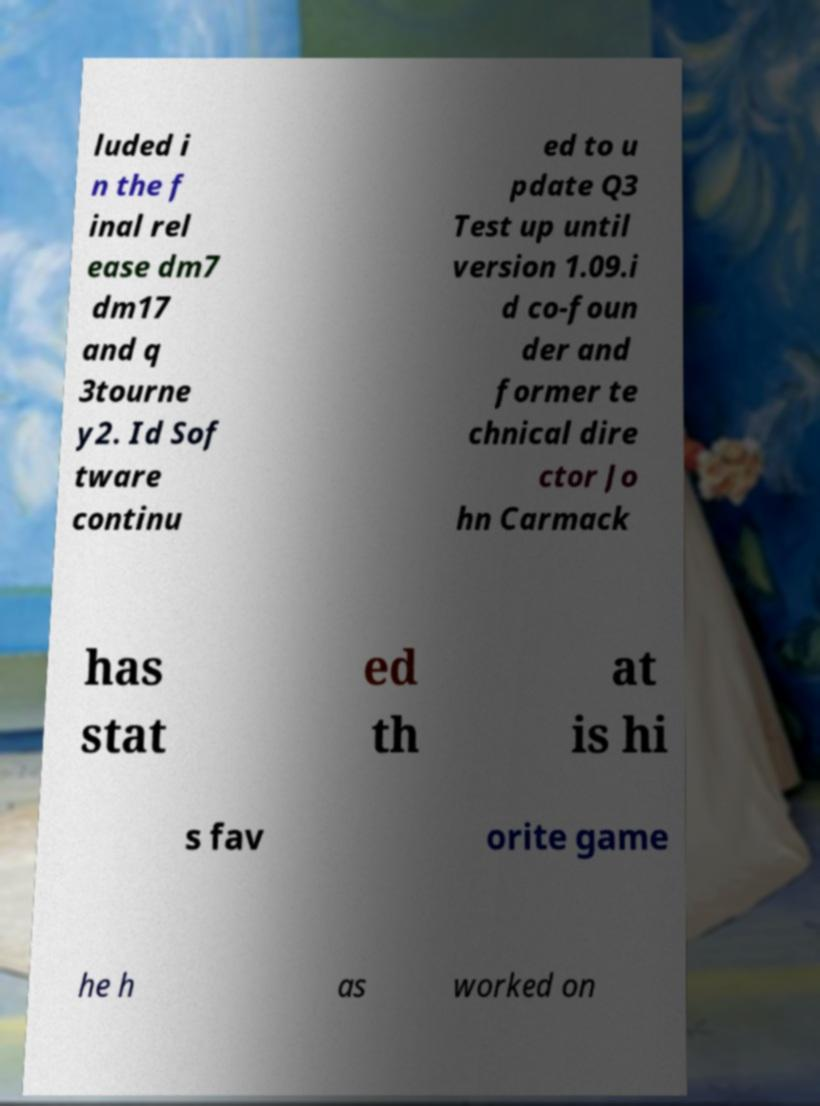Could you extract and type out the text from this image? luded i n the f inal rel ease dm7 dm17 and q 3tourne y2. Id Sof tware continu ed to u pdate Q3 Test up until version 1.09.i d co-foun der and former te chnical dire ctor Jo hn Carmack has stat ed th at is hi s fav orite game he h as worked on 